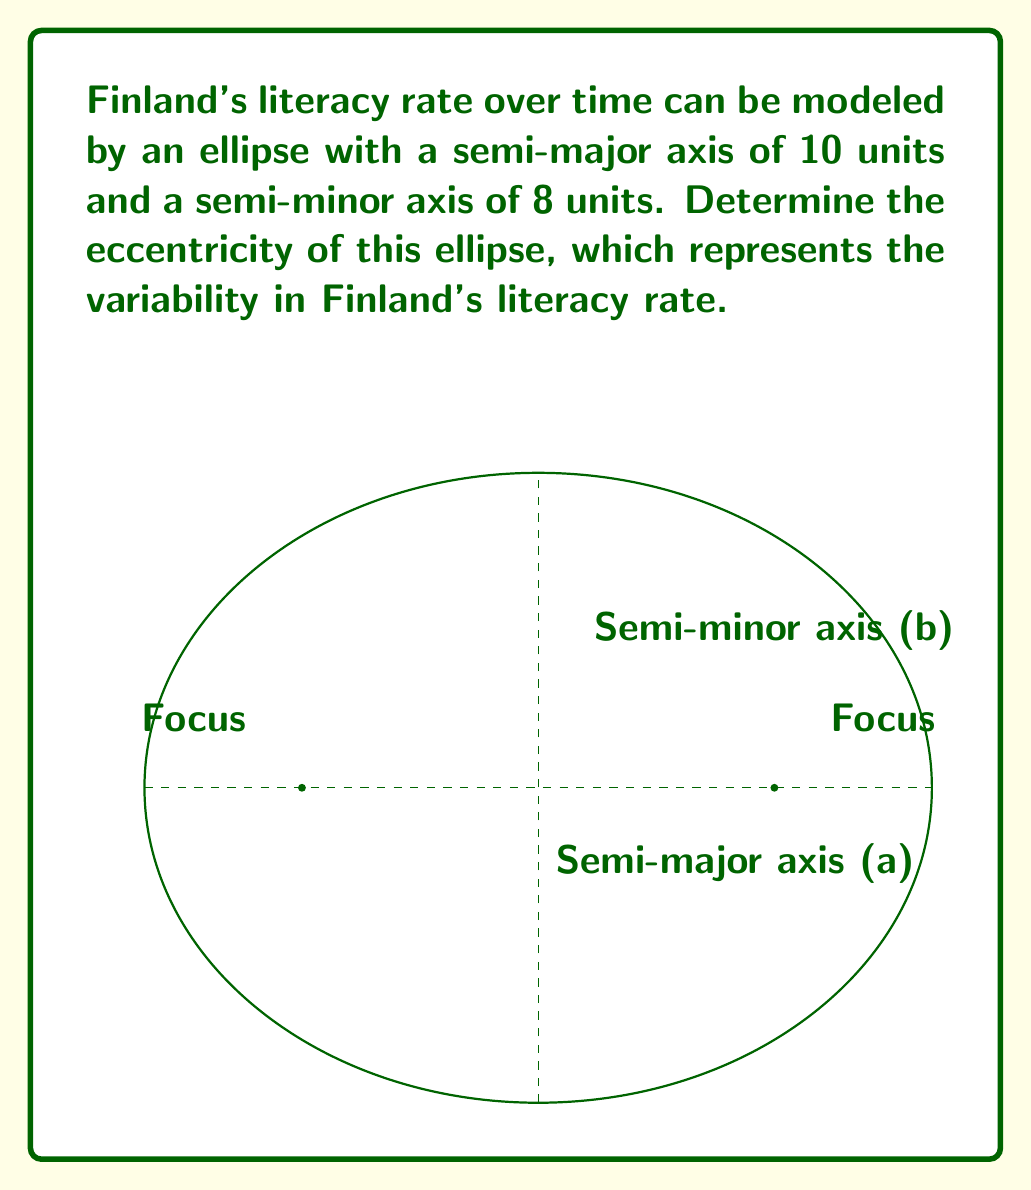Provide a solution to this math problem. To solve this problem, we'll follow these steps:

1) The eccentricity (e) of an ellipse is defined as the ratio of the distance between the center and a focus to the length of the semi-major axis. It can be calculated using the formula:

   $$e = \frac{\sqrt{a^2 - b^2}}{a}$$

   where $a$ is the semi-major axis and $b$ is the semi-minor axis.

2) We are given:
   - Semi-major axis (a) = 10 units
   - Semi-minor axis (b) = 8 units

3) Let's substitute these values into the formula:

   $$e = \frac{\sqrt{10^2 - 8^2}}{10}$$

4) Simplify inside the square root:

   $$e = \frac{\sqrt{100 - 64}}{10} = \frac{\sqrt{36}}{10}$$

5) Simplify the square root:

   $$e = \frac{6}{10}$$

6) Reduce the fraction:

   $$e = \frac{3}{5} = 0.6$$

This eccentricity value of 0.6 indicates a moderately elliptical shape, suggesting some variability in Finland's literacy rate over time, while still maintaining a relatively stable trend.
Answer: $\frac{3}{5}$ or $0.6$ 